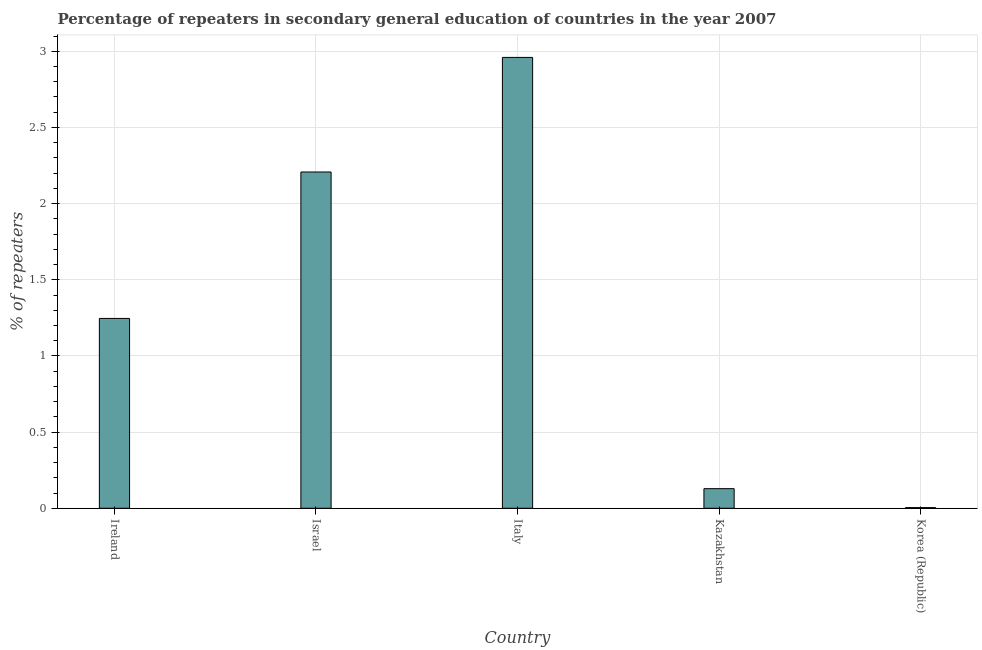Does the graph contain any zero values?
Provide a succinct answer. No. What is the title of the graph?
Offer a very short reply. Percentage of repeaters in secondary general education of countries in the year 2007. What is the label or title of the Y-axis?
Provide a short and direct response. % of repeaters. What is the percentage of repeaters in Korea (Republic)?
Your answer should be compact. 0. Across all countries, what is the maximum percentage of repeaters?
Give a very brief answer. 2.96. Across all countries, what is the minimum percentage of repeaters?
Keep it short and to the point. 0. In which country was the percentage of repeaters minimum?
Your answer should be very brief. Korea (Republic). What is the sum of the percentage of repeaters?
Provide a succinct answer. 6.55. What is the difference between the percentage of repeaters in Ireland and Kazakhstan?
Your response must be concise. 1.12. What is the average percentage of repeaters per country?
Offer a very short reply. 1.31. What is the median percentage of repeaters?
Your response must be concise. 1.25. In how many countries, is the percentage of repeaters greater than 1.5 %?
Keep it short and to the point. 2. What is the ratio of the percentage of repeaters in Kazakhstan to that in Korea (Republic)?
Make the answer very short. 29.99. Is the percentage of repeaters in Israel less than that in Italy?
Provide a short and direct response. Yes. What is the difference between the highest and the second highest percentage of repeaters?
Your answer should be compact. 0.75. Is the sum of the percentage of repeaters in Israel and Korea (Republic) greater than the maximum percentage of repeaters across all countries?
Your answer should be very brief. No. What is the difference between the highest and the lowest percentage of repeaters?
Offer a terse response. 2.96. Are all the bars in the graph horizontal?
Ensure brevity in your answer.  No. What is the difference between two consecutive major ticks on the Y-axis?
Make the answer very short. 0.5. Are the values on the major ticks of Y-axis written in scientific E-notation?
Offer a terse response. No. What is the % of repeaters of Ireland?
Offer a terse response. 1.25. What is the % of repeaters in Israel?
Keep it short and to the point. 2.21. What is the % of repeaters of Italy?
Provide a succinct answer. 2.96. What is the % of repeaters of Kazakhstan?
Provide a short and direct response. 0.13. What is the % of repeaters of Korea (Republic)?
Make the answer very short. 0. What is the difference between the % of repeaters in Ireland and Israel?
Give a very brief answer. -0.96. What is the difference between the % of repeaters in Ireland and Italy?
Provide a succinct answer. -1.71. What is the difference between the % of repeaters in Ireland and Kazakhstan?
Your response must be concise. 1.12. What is the difference between the % of repeaters in Ireland and Korea (Republic)?
Offer a terse response. 1.24. What is the difference between the % of repeaters in Israel and Italy?
Provide a short and direct response. -0.75. What is the difference between the % of repeaters in Israel and Kazakhstan?
Ensure brevity in your answer.  2.08. What is the difference between the % of repeaters in Israel and Korea (Republic)?
Give a very brief answer. 2.2. What is the difference between the % of repeaters in Italy and Kazakhstan?
Provide a short and direct response. 2.83. What is the difference between the % of repeaters in Italy and Korea (Republic)?
Offer a very short reply. 2.96. What is the difference between the % of repeaters in Kazakhstan and Korea (Republic)?
Give a very brief answer. 0.12. What is the ratio of the % of repeaters in Ireland to that in Israel?
Provide a short and direct response. 0.56. What is the ratio of the % of repeaters in Ireland to that in Italy?
Keep it short and to the point. 0.42. What is the ratio of the % of repeaters in Ireland to that in Kazakhstan?
Offer a very short reply. 9.69. What is the ratio of the % of repeaters in Ireland to that in Korea (Republic)?
Your response must be concise. 290.51. What is the ratio of the % of repeaters in Israel to that in Italy?
Offer a very short reply. 0.75. What is the ratio of the % of repeaters in Israel to that in Kazakhstan?
Offer a very short reply. 17.16. What is the ratio of the % of repeaters in Israel to that in Korea (Republic)?
Your answer should be compact. 514.6. What is the ratio of the % of repeaters in Italy to that in Kazakhstan?
Offer a terse response. 23. What is the ratio of the % of repeaters in Italy to that in Korea (Republic)?
Provide a short and direct response. 689.93. What is the ratio of the % of repeaters in Kazakhstan to that in Korea (Republic)?
Provide a succinct answer. 29.99. 